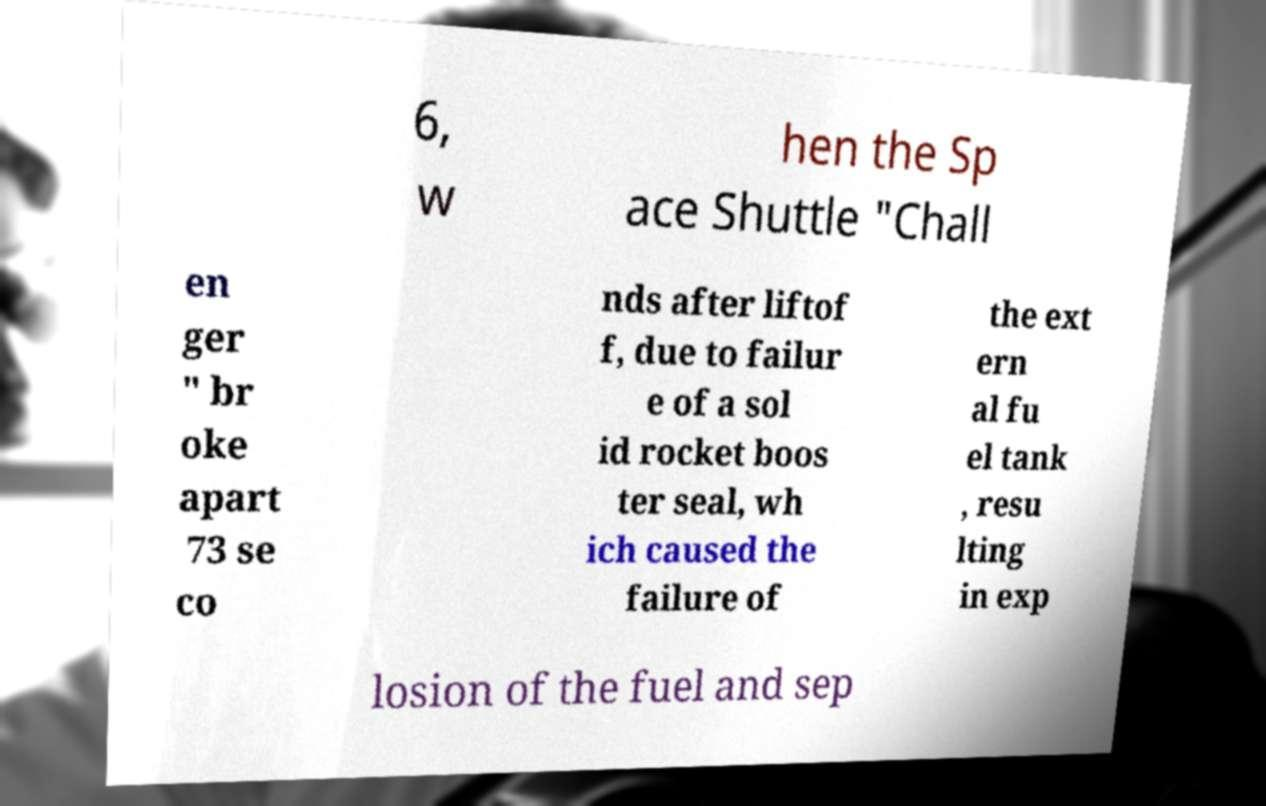There's text embedded in this image that I need extracted. Can you transcribe it verbatim? 6, w hen the Sp ace Shuttle "Chall en ger " br oke apart 73 se co nds after liftof f, due to failur e of a sol id rocket boos ter seal, wh ich caused the failure of the ext ern al fu el tank , resu lting in exp losion of the fuel and sep 